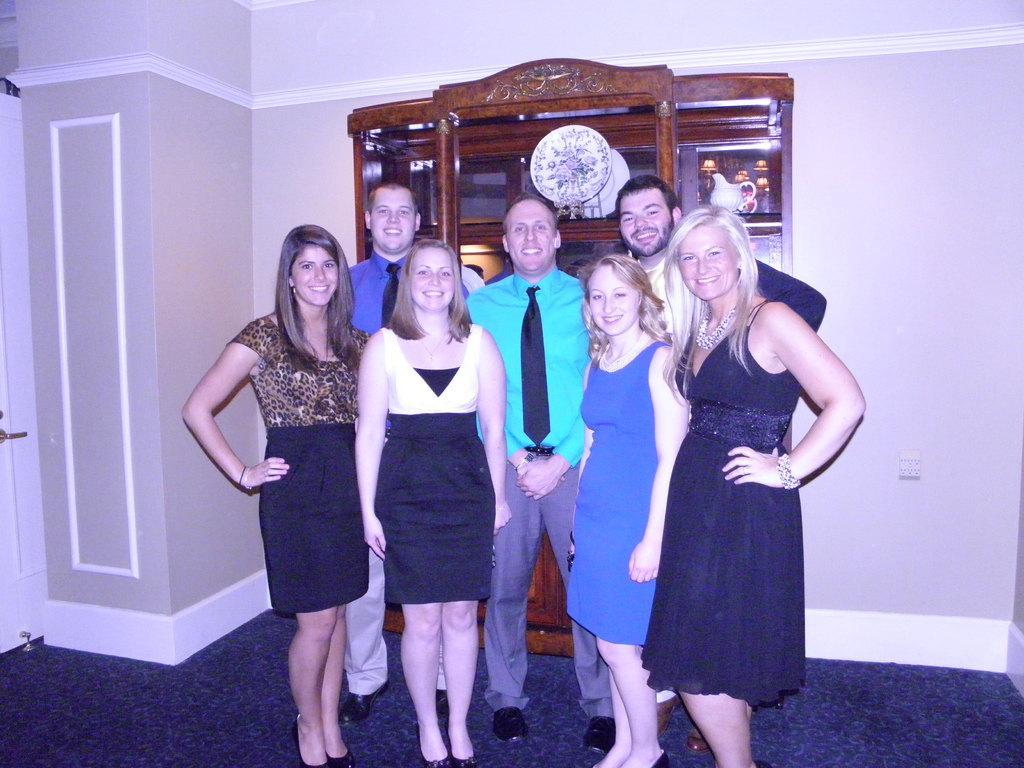In one or two sentences, can you explain what this image depicts? In this image there is a group of people standing with a smile on their face are posing for the camera, behind them there is a wooden cupboard with some objects on it, behind the wooden cupboard there is a wall. 